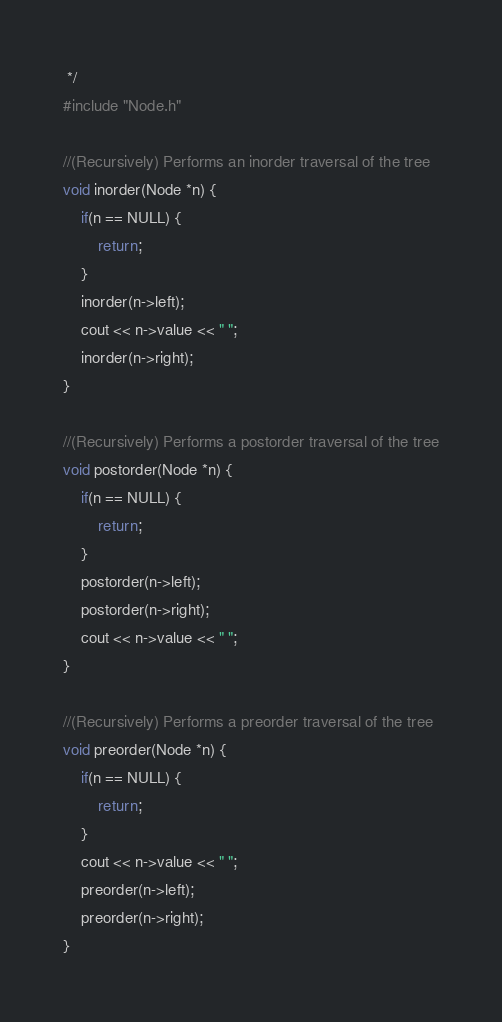Convert code to text. <code><loc_0><loc_0><loc_500><loc_500><_C_> */
#include "Node.h"

//(Recursively) Performs an inorder traversal of the tree
void inorder(Node *n) {
    if(n == NULL) {
        return;
    }
    inorder(n->left);
    cout << n->value << " ";
    inorder(n->right);
}

//(Recursively) Performs a postorder traversal of the tree
void postorder(Node *n) {
    if(n == NULL) {
        return;
    }
    postorder(n->left);
    postorder(n->right);
    cout << n->value << " ";
}

//(Recursively) Performs a preorder traversal of the tree
void preorder(Node *n) {
    if(n == NULL) {
        return;
    }
    cout << n->value << " ";
    preorder(n->left);
    preorder(n->right);
}</code> 